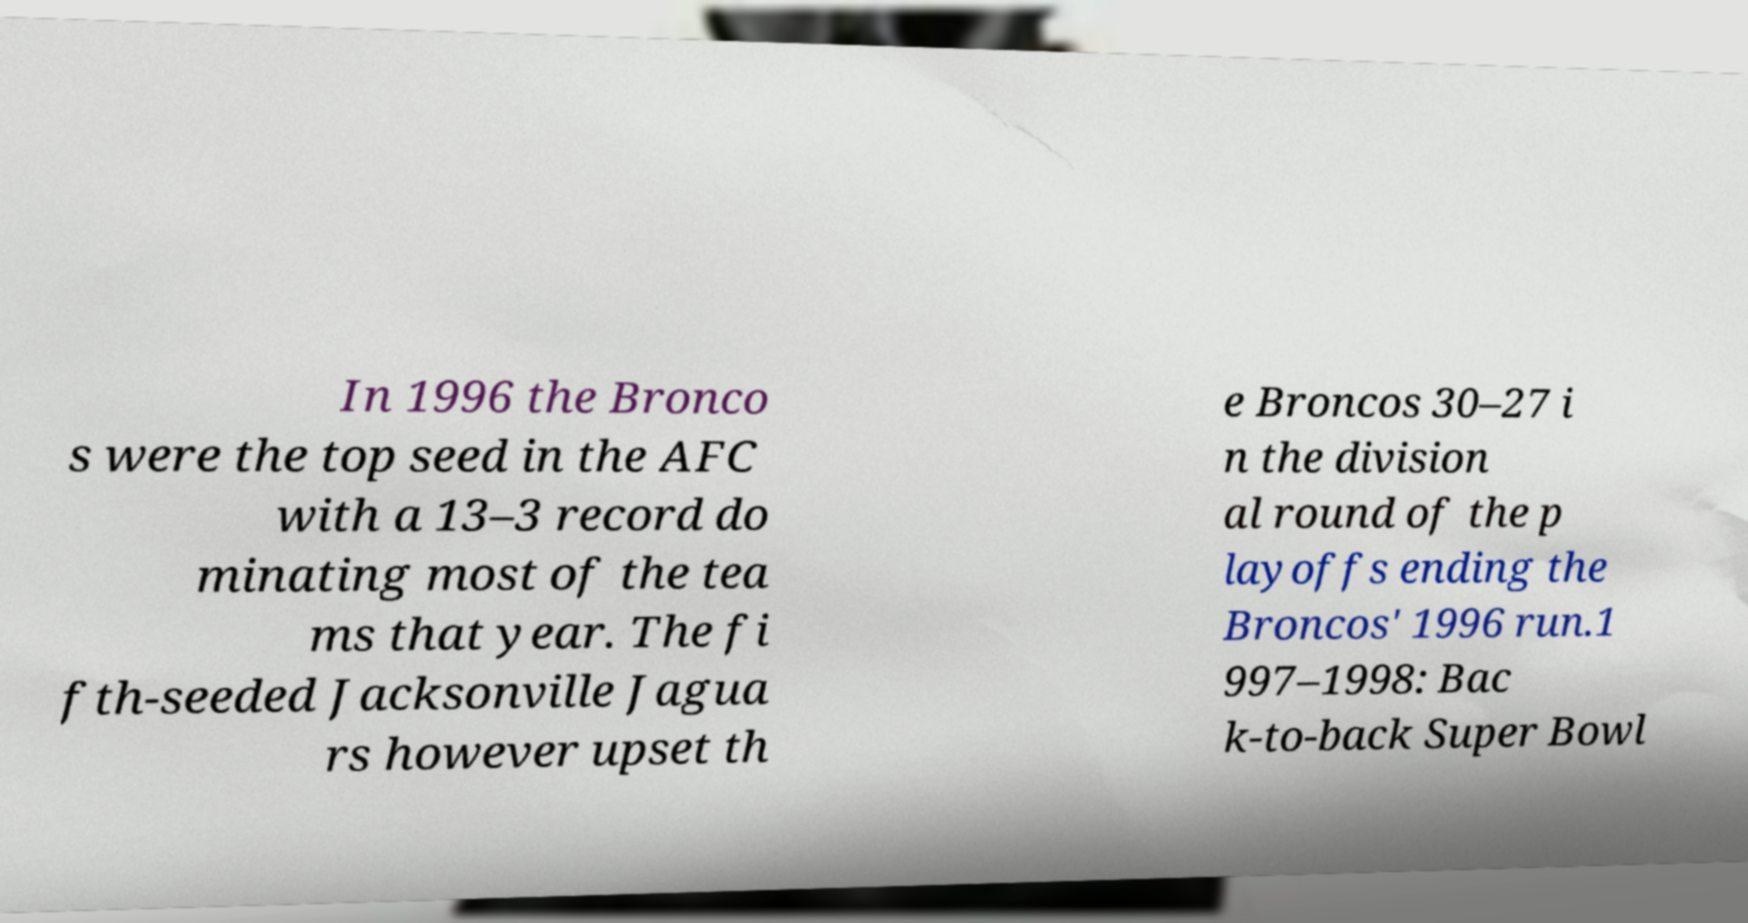There's text embedded in this image that I need extracted. Can you transcribe it verbatim? In 1996 the Bronco s were the top seed in the AFC with a 13–3 record do minating most of the tea ms that year. The fi fth-seeded Jacksonville Jagua rs however upset th e Broncos 30–27 i n the division al round of the p layoffs ending the Broncos' 1996 run.1 997–1998: Bac k-to-back Super Bowl 